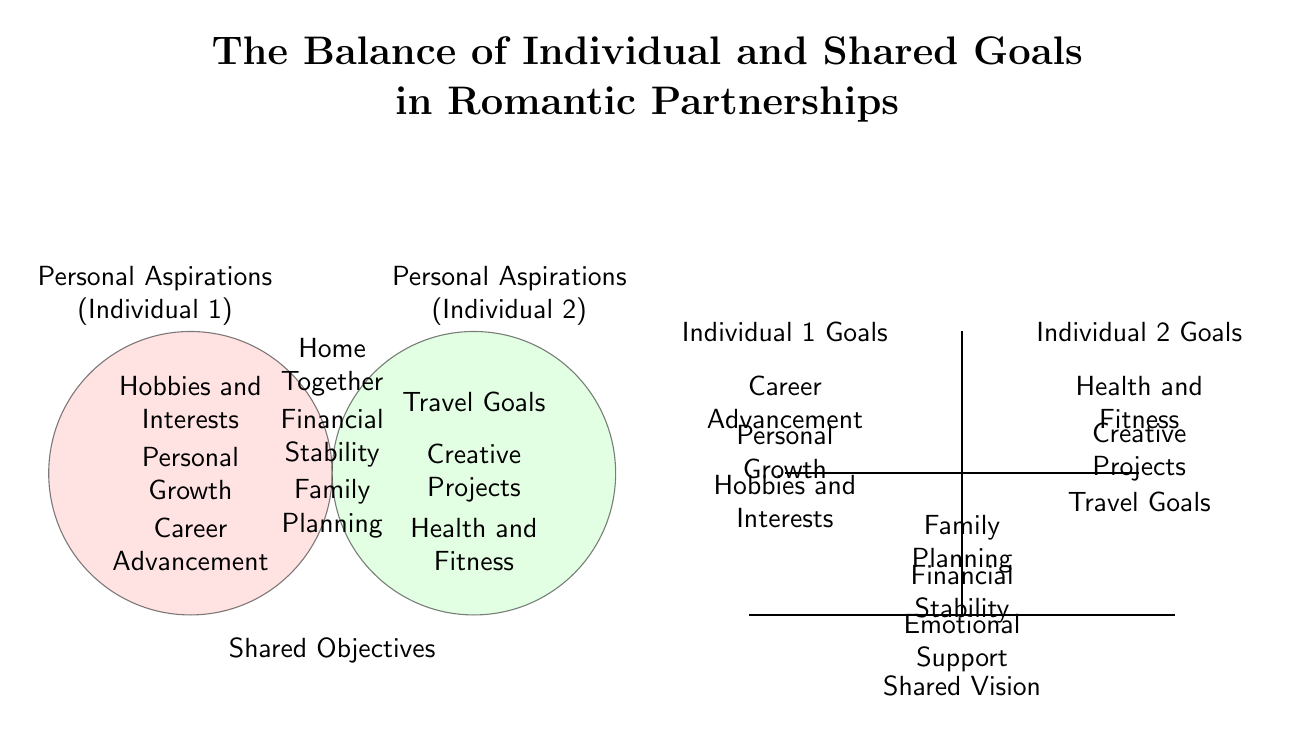What are the personal aspirations listed for Individual 1? The diagram shows three personal aspirations for Individual 1 in the left circle, which are "Career Advancement," "Personal Growth," and "Hobbies and Interests."
Answer: Career Advancement, Personal Growth, Hobbies and Interests What is one shared objective depicted in the diagram? The shared section of the Venn diagram lists three shared objectives. One example from this list is "Family Planning," which is clearly marked in the central overlap area.
Answer: Family Planning How many personal aspirations are associated with Individual 2? The right circle represents Individual 2's personal aspirations. There are three aspirations listed: "Health and Fitness," "Creative Projects," and "Travel Goals," making a total of three.
Answer: 3 What is the relationship between "Personal Growth" and "Family Planning"? "Personal Growth" is listed under Individual 1's aspirations, while "Family Planning" is found in the shared objectives. This indicates that while "Personal Growth" is an individual goal, it may support or influence shared goals like "Family Planning."
Answer: Individual goal and Shared objective Which individual has "Health and Fitness" as a goal? The diagram places "Health and Fitness" under Individual 2's aspirations in the right circle, indicating that it is a goal solely for them.
Answer: Individual 2 What does the balance scale represent in the diagram? The balance scale visually represents the equilibrium between individual goals and shared vision. This emphasizes that maintaining harmony between personal aspirations and shared objectives is crucial for a healthy relationship.
Answer: Balance of goals Which personal aspiration is closest to the shared vision on the balance scale? In the balance scale, "Emotional Support" is listed closest to the shared vision. It indicates that support is critical to maintaining relationship balance and harmony.
Answer: Emotional Support 